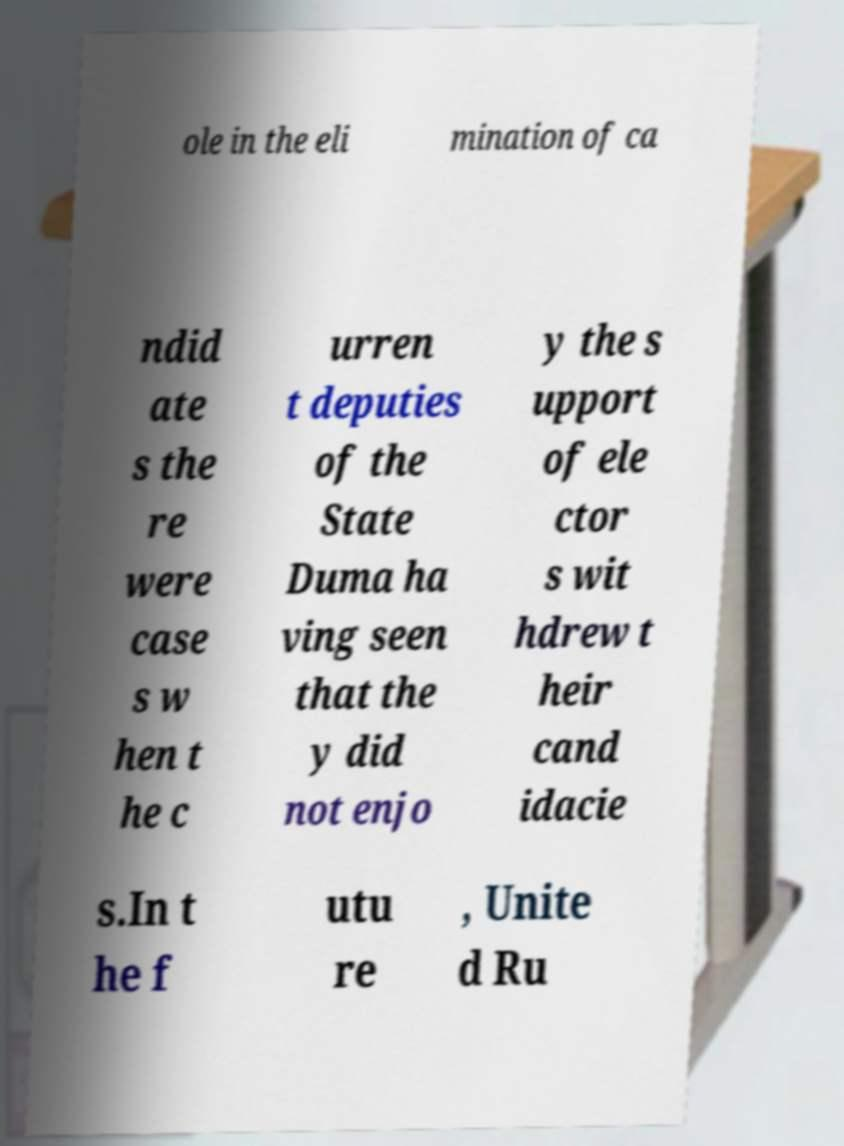Could you extract and type out the text from this image? ole in the eli mination of ca ndid ate s the re were case s w hen t he c urren t deputies of the State Duma ha ving seen that the y did not enjo y the s upport of ele ctor s wit hdrew t heir cand idacie s.In t he f utu re , Unite d Ru 